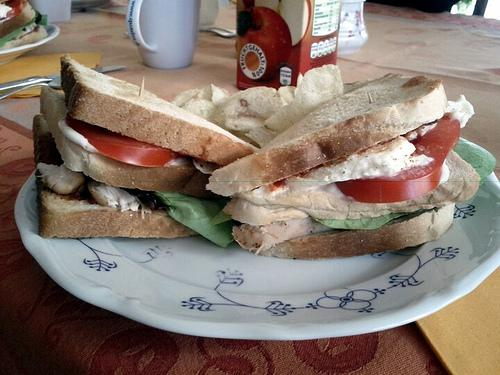Question: what else is on the plate?
Choices:
A. Pizza.
B. My fingers.
C. A napkin.
D. Potato chips.
Answer with the letter. Answer: D Question: when was this photo taken?
Choices:
A. Dinnertime.
B. Breakfast time.
C. Lunchtime.
D. Snack time.
Answer with the letter. Answer: C Question: how many sandwich halves are there?
Choices:
A. 4.
B. 1.
C. 2.
D. 0.
Answer with the letter. Answer: C Question: why is the sandwich on a plate?
Choices:
A. To keep it safe.
B. To keep it off the table.
C. To throw it away.
D. To make it dirty.
Answer with the letter. Answer: B Question: how is the sandwich cut?
Choices:
A. No crust.
B. Horizontally.
C. Vertically.
D. Diagonally.
Answer with the letter. Answer: D Question: what color is the mug?
Choices:
A. Black.
B. Gray.
C. Blue.
D. White.
Answer with the letter. Answer: D 